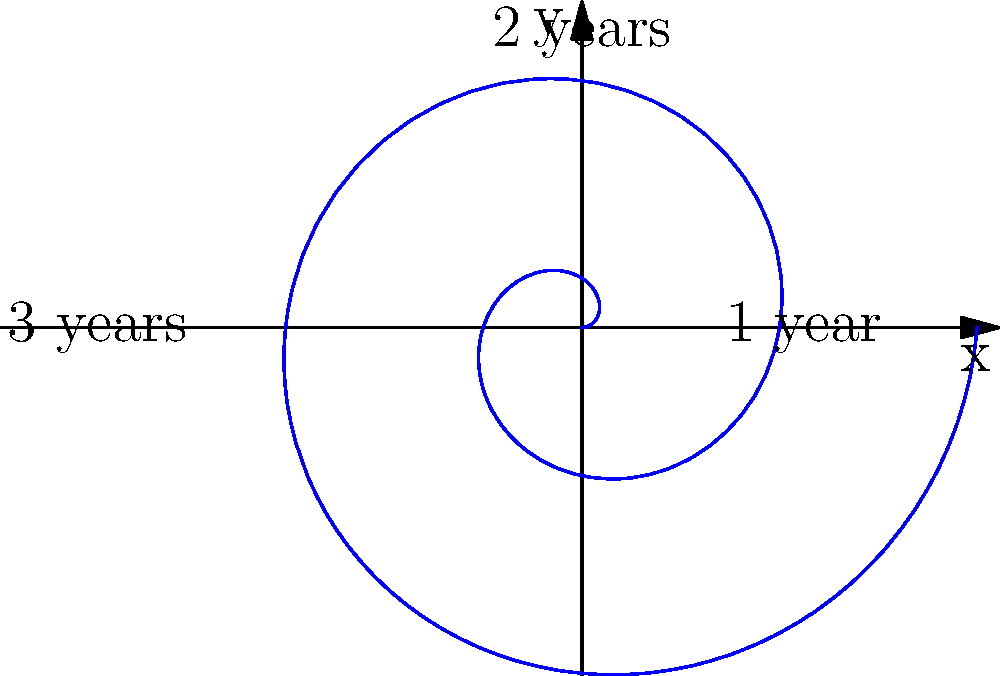As a horticulturist specializing in topiary art, you're designing a spiral-shaped topiary. The growth pattern of the plant can be modeled by the polar equation $r = 0.2\theta$, where $r$ is the distance from the center in meters, and $\theta$ is the angle in radians. If the plant grows continuously for 3 years, how many complete revolutions will the spiral make? To solve this problem, let's follow these steps:

1) In polar coordinates, one complete revolution corresponds to an angle of $2\pi$ radians.

2) We need to determine the total angle $\theta$ after 3 years of growth.

3) The equation $r = 0.2\theta$ relates the radius to the angle. At the end of 3 years, the outermost point of the spiral will have the largest radius.

4) From the graph, we can see that after 3 years, the spiral has made slightly more than 2 complete revolutions.

5) To be precise, we need to calculate the exact angle:
   - The graph shows that after 3 years, the spiral reaches a radius of about 2.4 meters.
   - Using the equation: $2.4 = 0.2\theta$
   - Solving for $\theta$: $\theta = 2.4 / 0.2 = 12$

6) The angle $\theta = 12$ radians corresponds to the total angular displacement after 3 years.

7) To find the number of complete revolutions, we divide this by $2\pi$:
   $12 / (2\pi) \approx 1.91$ revolutions

8) Therefore, the spiral makes 1 complete revolution, and is close to completing the second one.
Answer: 1 complete revolution 